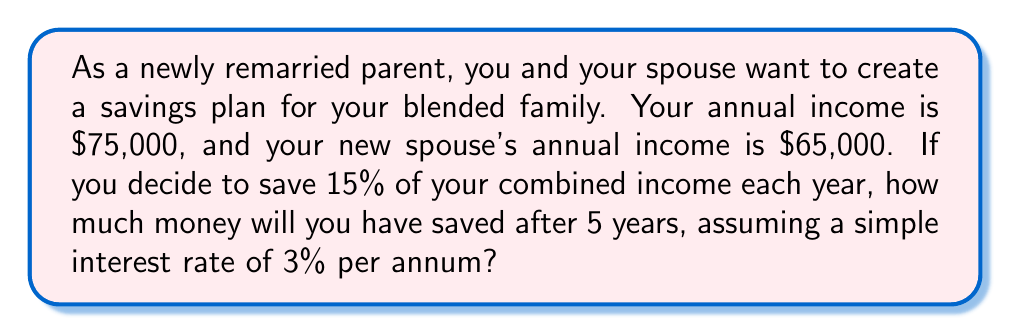Give your solution to this math problem. Let's break this problem down into steps:

1. Calculate the combined annual income:
   $75,000 + $65,000 = $140,000

2. Calculate the annual savings (15% of combined income):
   $140,000 * 0.15 = $21,000

3. Calculate the total savings over 5 years (without interest):
   $21,000 * 5 = $105,000

4. Calculate the interest earned using the simple interest formula:
   $I = P * r * t$
   Where:
   $I$ = Interest
   $P$ = Principal (total savings)
   $r$ = Annual interest rate
   $t$ = Time in years

   $I = $105,000 * 0.03 * 5 = $15,750

5. Calculate the total savings including interest:
   Total savings = Principal + Interest
   $105,000 + $15,750 = $120,750

Therefore, after 5 years, the family will have saved $120,750.
Answer: $$120,750$$ 